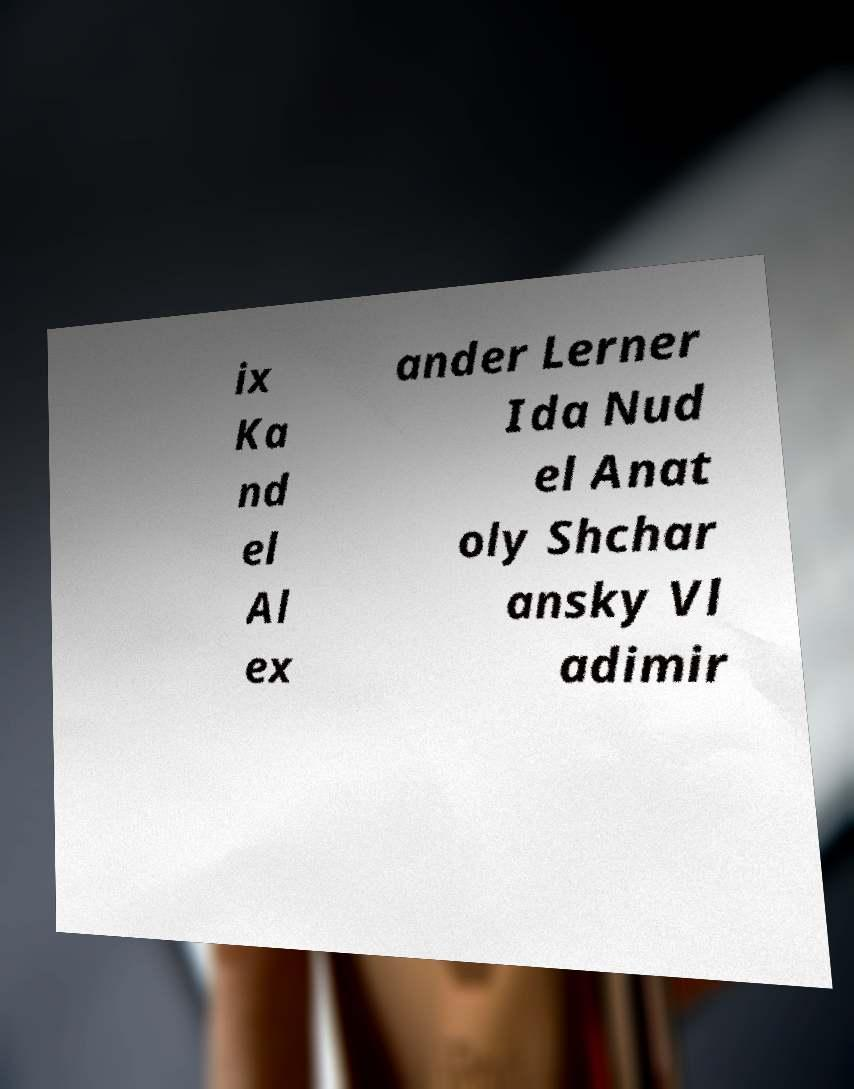Can you accurately transcribe the text from the provided image for me? ix Ka nd el Al ex ander Lerner Ida Nud el Anat oly Shchar ansky Vl adimir 